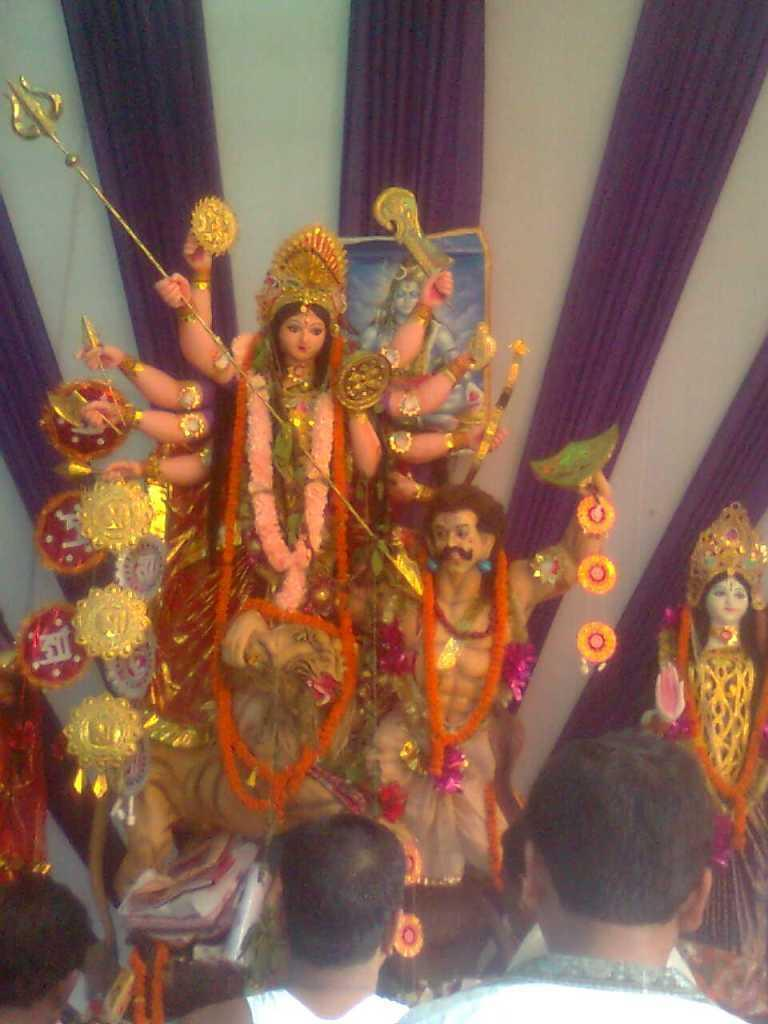What is present with the idols in the image? There are garlands with the idols in the image. Who can be seen at the bottom of the image? There are people at the bottom of the image. What can be seen in the background of the image? There are curtains in the background of the image. Can you see any cherries on the dress of the person at the bottom of the image? There is no dress or cherries mentioned in the image; it only states that there are people at the bottom. 